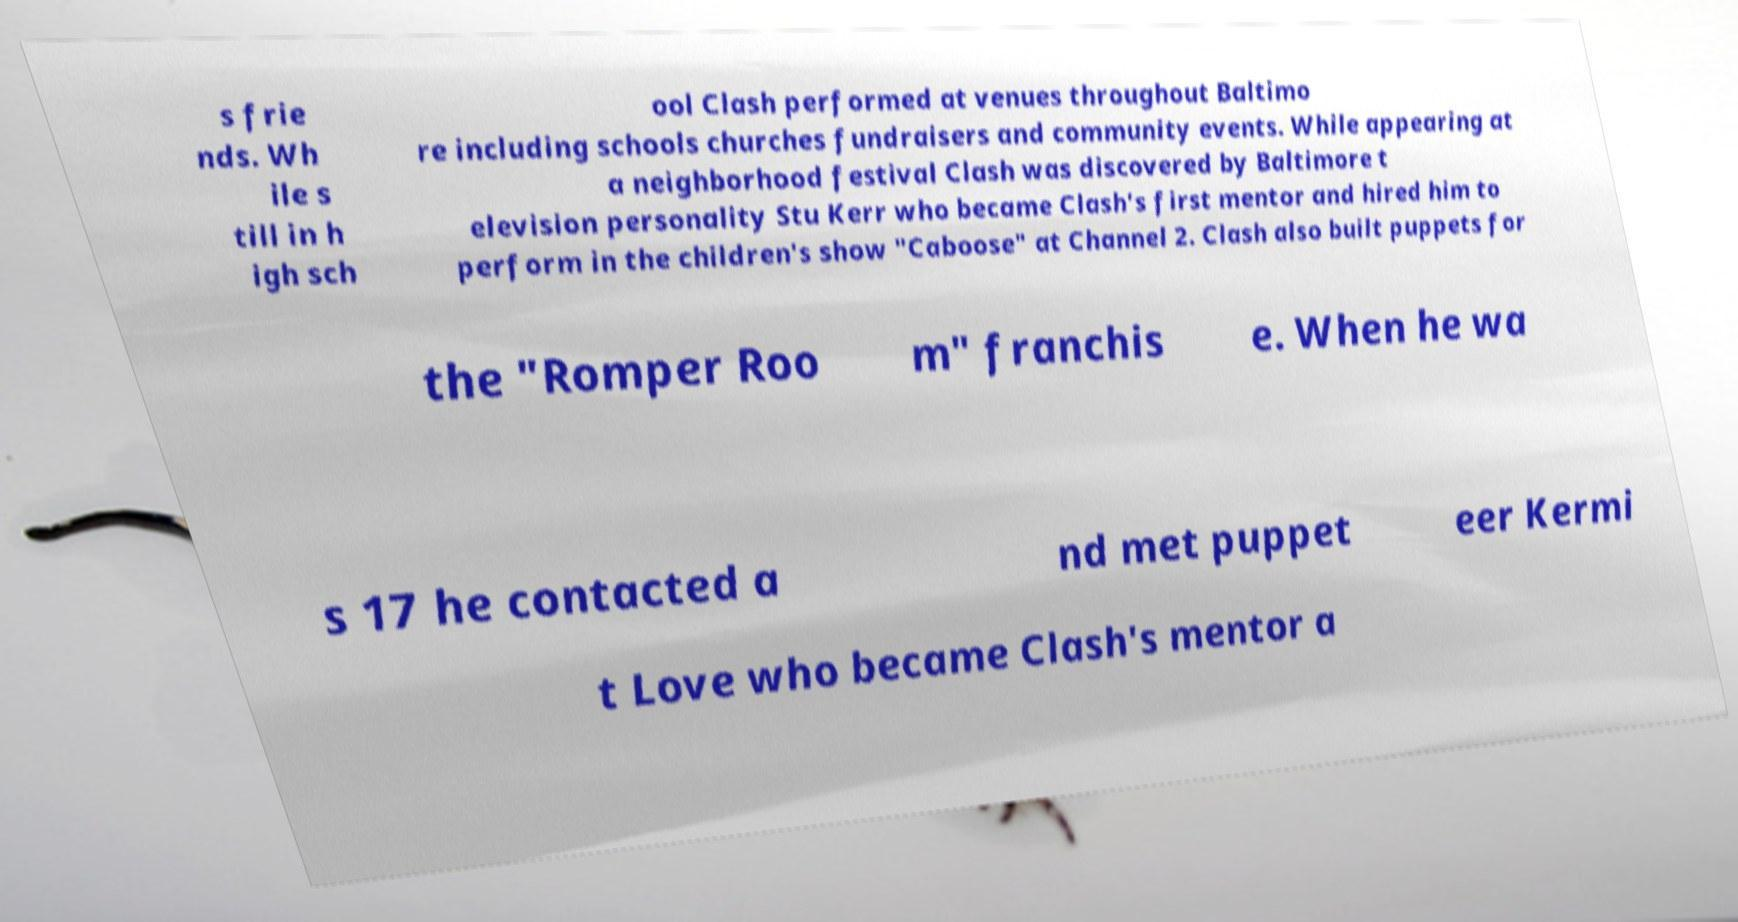Please identify and transcribe the text found in this image. s frie nds. Wh ile s till in h igh sch ool Clash performed at venues throughout Baltimo re including schools churches fundraisers and community events. While appearing at a neighborhood festival Clash was discovered by Baltimore t elevision personality Stu Kerr who became Clash's first mentor and hired him to perform in the children's show "Caboose" at Channel 2. Clash also built puppets for the "Romper Roo m" franchis e. When he wa s 17 he contacted a nd met puppet eer Kermi t Love who became Clash's mentor a 